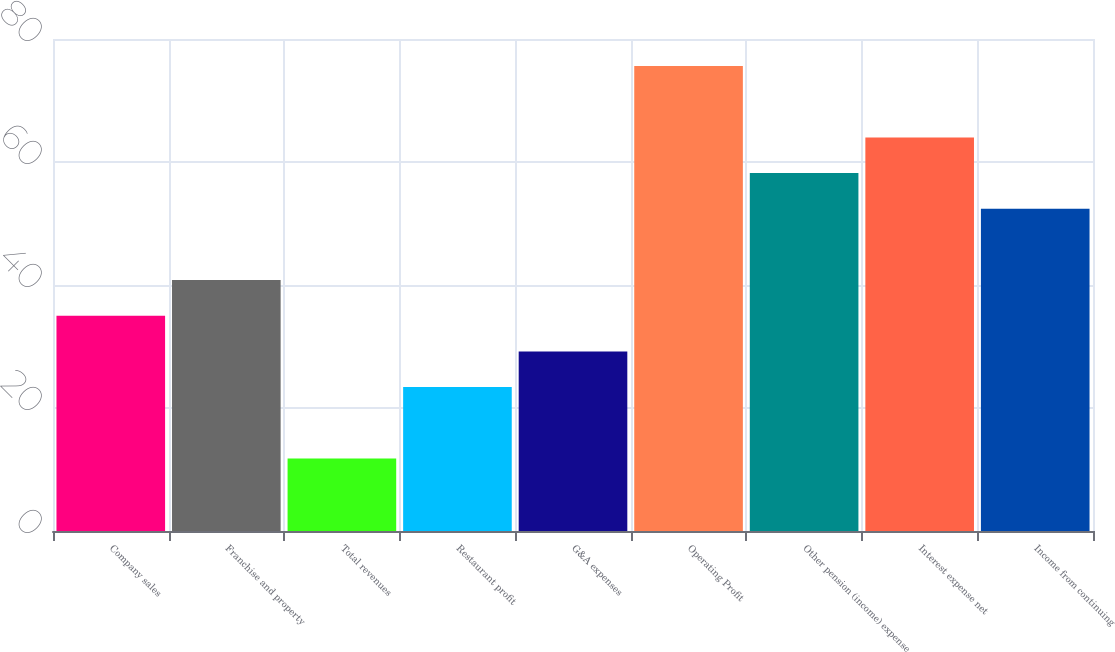Convert chart. <chart><loc_0><loc_0><loc_500><loc_500><bar_chart><fcel>Company sales<fcel>Franchise and property<fcel>Total revenues<fcel>Restaurant profit<fcel>G&A expenses<fcel>Operating Profit<fcel>Other pension (income) expense<fcel>Interest expense net<fcel>Income from continuing<nl><fcel>35<fcel>40.8<fcel>11.8<fcel>23.4<fcel>29.2<fcel>75.6<fcel>58.2<fcel>64<fcel>52.4<nl></chart> 